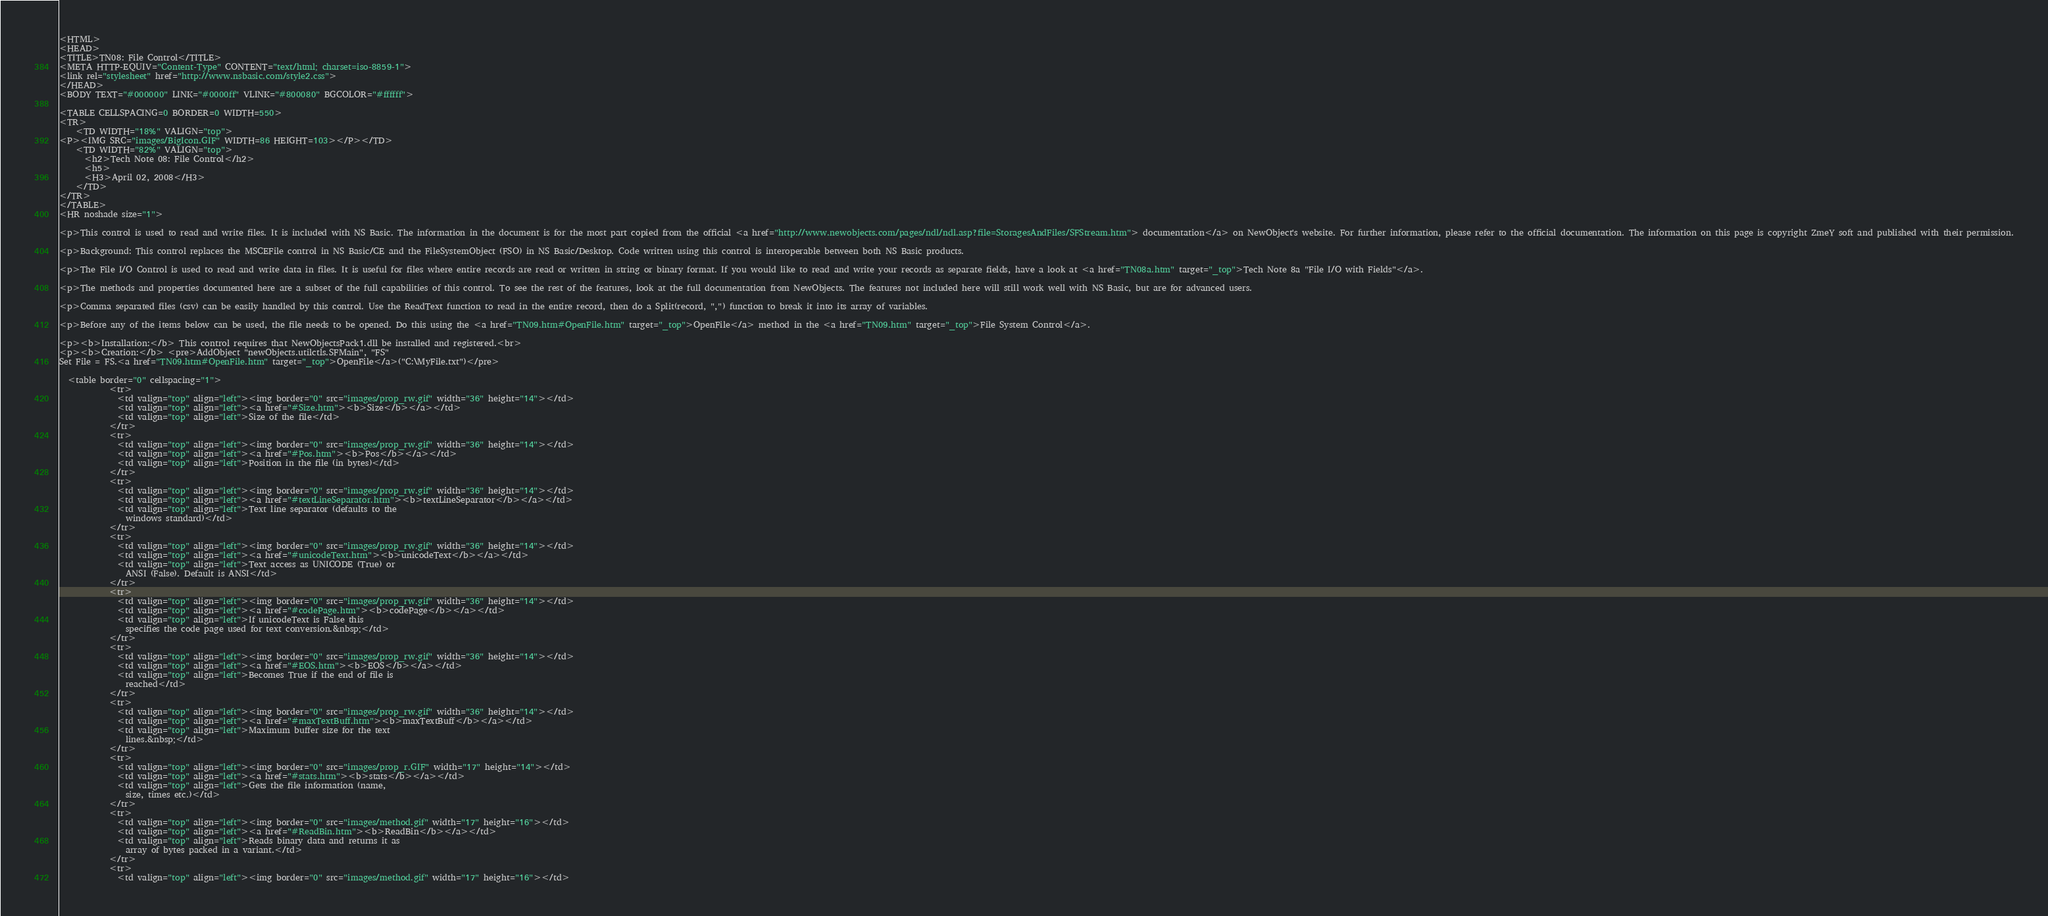<code> <loc_0><loc_0><loc_500><loc_500><_HTML_><HTML>
<HEAD>
<TITLE>TN08: File Control</TITLE>
<META HTTP-EQUIV="Content-Type" CONTENT="text/html; charset=iso-8859-1">
<link rel="stylesheet" href="http://www.nsbasic.com/style2.css">
</HEAD>
<BODY TEXT="#000000" LINK="#0000ff" VLINK="#800080" BGCOLOR="#ffffff">

<TABLE CELLSPACING=0 BORDER=0 WIDTH=550>
<TR>
	<TD WIDTH="18%" VALIGN="top">
<P><IMG SRC="images/BigIcon.GIF" WIDTH=86 HEIGHT=103></P></TD>
    <TD WIDTH="82%" VALIGN="top">
	  <h2>Tech Note 08: File Control</h2>
	  <h5>
      <H3>April 02, 2008</H3>
	</TD>
</TR>
</TABLE>
<HR noshade size="1">

<p>This control is used to read and write files. It is included with NS Basic. The information in the document is for the most part copied from the official <a href="http://www.newobjects.com/pages/ndl/ndl.asp?file=StoragesAndFiles/SFStream.htm"> documentation</a> on NewObject's website. For further information, please refer to the official documentation. The information on this page is copyright ZmeY soft and published with their permission.

<p>Background: This control replaces the MSCEFile control in NS Basic/CE and the FileSystemObject (FSO) in NS Basic/Desktop. Code written using this control is interoperable between both NS Basic products.

<p>The File I/O Control is used to read and write data in files. It is useful for files where entire records are read or written in string or binary format. If you would like to read and write your records as separate fields, have a look at <a href="TN08a.htm" target="_top">Tech Note 8a "File I/O with Fields"</a>.

<p>The methods and properties documented here are a subset of the full capabilities of this control. To see the rest of the features, look at the full documentation from NewObjects. The features not included here will still work well with NS Basic, but are for advanced users.

<p>Comma separated files (csv) can be easily handled by this control. Use the ReadText function to read in the entire record, then do a Split(record, ",") function to break it into its array of variables.

<p>Before any of the items below can be used, the file needs to be opened. Do this using the <a href="TN09.htm#OpenFile.htm" target="_top">OpenFile</a> method in the <a href="TN09.htm" target="_top">File System Control</a>.

<p><b>Installation:</b> This control requires that NewObjectsPack1.dll be installed and registered.<br>
<p><b>Creation:</b> <pre>AddObject "newObjects.utilctls.SFMain", "FS"
Set File = FS.<a href="TN09.htm#OpenFile.htm" target="_top">OpenFile</a>("C:\MyFile.txt")</pre>
        
  <table border="0" cellspacing="1">
            <tr>
              <td valign="top" align="left"><img border="0" src="images/prop_rw.gif" width="36" height="14"></td>
              <td valign="top" align="left"><a href="#Size.htm"><b>Size</b></a></td>
              <td valign="top" align="left">Size of the file</td>
            </tr>
            <tr>
              <td valign="top" align="left"><img border="0" src="images/prop_rw.gif" width="36" height="14"></td>
              <td valign="top" align="left"><a href="#Pos.htm"><b>Pos</b></a></td>
              <td valign="top" align="left">Position in the file (in bytes)</td>
            </tr>
            <tr>
              <td valign="top" align="left"><img border="0" src="images/prop_rw.gif" width="36" height="14"></td>
              <td valign="top" align="left"><a href="#textLineSeparator.htm"><b>textLineSeparator</b></a></td>
              <td valign="top" align="left">Text line separator (defaults to the
                windows standard)</td>
            </tr>
            <tr>
              <td valign="top" align="left"><img border="0" src="images/prop_rw.gif" width="36" height="14"></td>
              <td valign="top" align="left"><a href="#unicodeText.htm"><b>unicodeText</b></a></td>
              <td valign="top" align="left">Text access as UNICODE (True) or
                ANSI (False). Default is ANSI</td>
            </tr>
            <tr>
              <td valign="top" align="left"><img border="0" src="images/prop_rw.gif" width="36" height="14"></td>
              <td valign="top" align="left"><a href="#codePage.htm"><b>codePage</b></a></td>
              <td valign="top" align="left">If unicodeText is False this
                specifies the code page used for text conversion.&nbsp;</td>
            </tr>
            <tr>
              <td valign="top" align="left"><img border="0" src="images/prop_rw.gif" width="36" height="14"></td>
              <td valign="top" align="left"><a href="#EOS.htm"><b>EOS</b></a></td>
              <td valign="top" align="left">Becomes True if the end of file is
                reached</td>
            </tr>
            <tr>
              <td valign="top" align="left"><img border="0" src="images/prop_rw.gif" width="36" height="14"></td>
              <td valign="top" align="left"><a href="#maxTextBuff.htm"><b>maxTextBuff</b></a></td>
              <td valign="top" align="left">Maximum buffer size for the text
                lines.&nbsp;</td>
            </tr>
            <tr>
              <td valign="top" align="left"><img border="0" src="images/prop_r.GIF" width="17" height="14"></td>
              <td valign="top" align="left"><a href="#stats.htm"><b>stats</b></a></td>
              <td valign="top" align="left">Gets the file information (name,
                size, times etc.)</td>
            </tr>
            <tr>
              <td valign="top" align="left"><img border="0" src="images/method.gif" width="17" height="16"></td>
              <td valign="top" align="left"><a href="#ReadBin.htm"><b>ReadBin</b></a></td>
              <td valign="top" align="left">Reads binary data and returns it as
                array of bytes packed in a variant.</td>
            </tr>
            <tr>
              <td valign="top" align="left"><img border="0" src="images/method.gif" width="17" height="16"></td></code> 